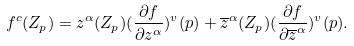<formula> <loc_0><loc_0><loc_500><loc_500>f ^ { c } ( Z _ { p } ) = z ^ { \alpha } ( Z _ { p } ) ( \frac { \partial f } { \partial z ^ { \alpha } } ) ^ { v } ( p ) + \overline { z } ^ { \alpha } ( Z _ { p } ) ( \frac { \partial f } { \partial \overline { z } ^ { \alpha } } ) ^ { v } ( p ) .</formula> 